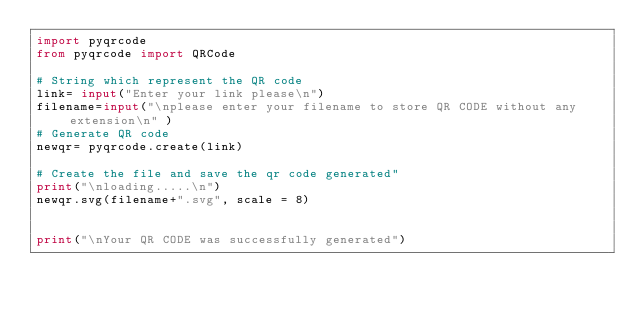Convert code to text. <code><loc_0><loc_0><loc_500><loc_500><_Python_>import pyqrcode 
from pyqrcode import QRCode 
  
# String which represent the QR code 
link= input("Enter your link please\n")
filename=input("\nplease enter your filename to store QR CODE without any extension\n" )
# Generate QR code 
newqr= pyqrcode.create(link) 
  
# Create the file and save the qr code generated"
print("\nloading.....\n")
newqr.svg(filename+".svg", scale = 8)


print("\nYour QR CODE was successfully generated")
</code> 